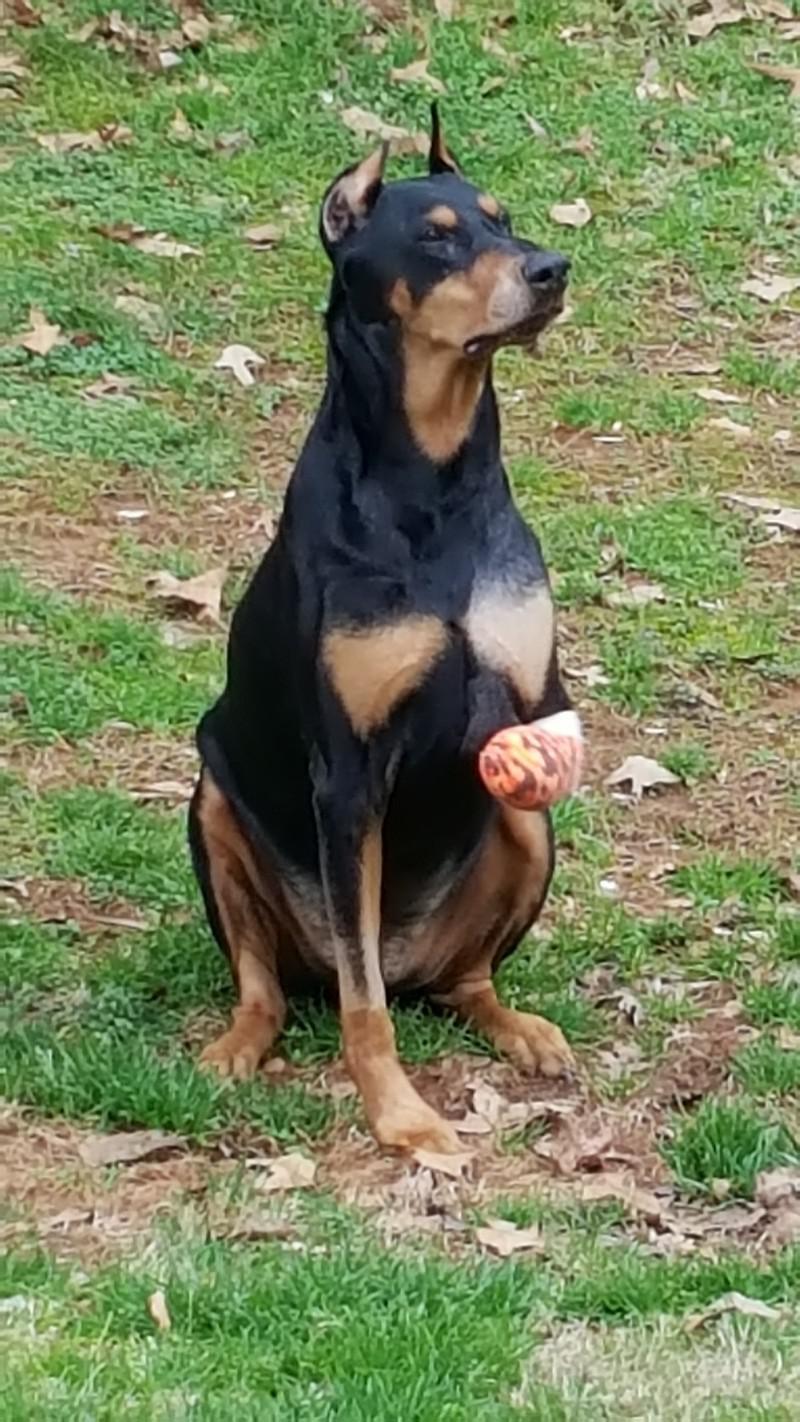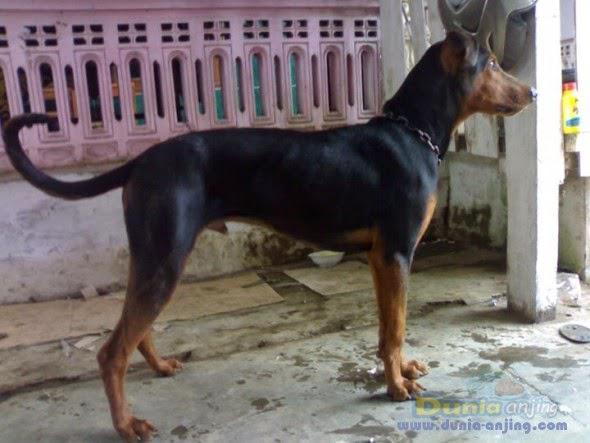The first image is the image on the left, the second image is the image on the right. For the images displayed, is the sentence "At least one of the dogs appears to be missing a back leg." factually correct? Answer yes or no. No. The first image is the image on the left, the second image is the image on the right. Considering the images on both sides, is "Each image includes a black-and-tan dog that is standing upright and is missing one limb." valid? Answer yes or no. No. 